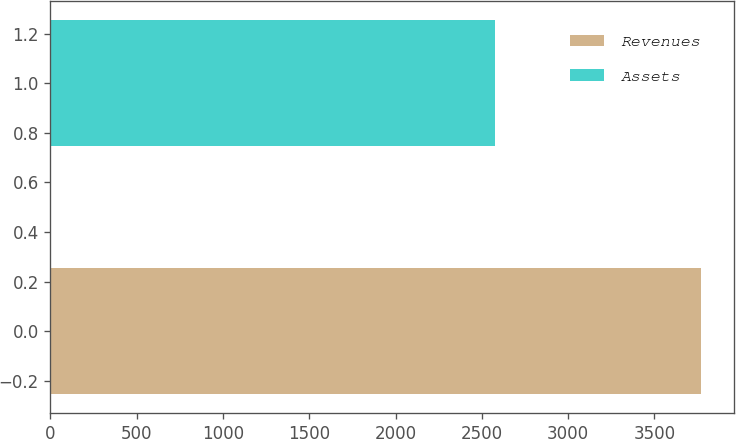Convert chart to OTSL. <chart><loc_0><loc_0><loc_500><loc_500><bar_chart><fcel>Revenues<fcel>Assets<nl><fcel>3771.9<fcel>2579.1<nl></chart> 